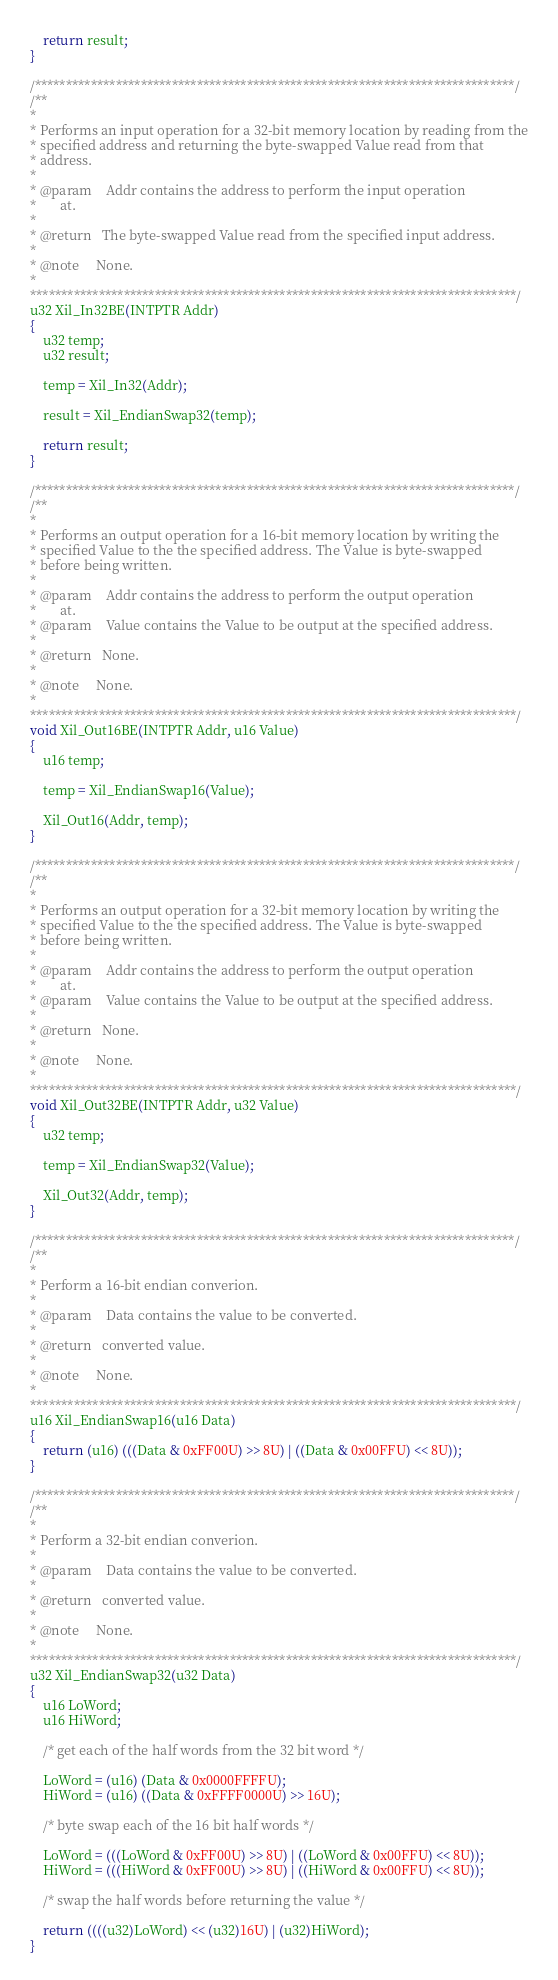Convert code to text. <code><loc_0><loc_0><loc_500><loc_500><_C_>	return result;
}

/*****************************************************************************/
/**
*
* Performs an input operation for a 32-bit memory location by reading from the
* specified address and returning the byte-swapped Value read from that
* address.
*
* @param	Addr contains the address to perform the input operation
*		at.
*
* @return	The byte-swapped Value read from the specified input address.
*
* @note		None.
*
******************************************************************************/
u32 Xil_In32BE(INTPTR Addr)
{
	u32 temp;
	u32 result;

	temp = Xil_In32(Addr);

	result = Xil_EndianSwap32(temp);

	return result;
}

/*****************************************************************************/
/**
*
* Performs an output operation for a 16-bit memory location by writing the
* specified Value to the the specified address. The Value is byte-swapped
* before being written.
*
* @param	Addr contains the address to perform the output operation
*		at.
* @param	Value contains the Value to be output at the specified address.
*
* @return	None.
*
* @note		None.
*
******************************************************************************/
void Xil_Out16BE(INTPTR Addr, u16 Value)
{
	u16 temp;

	temp = Xil_EndianSwap16(Value);

    Xil_Out16(Addr, temp);
}

/*****************************************************************************/
/**
*
* Performs an output operation for a 32-bit memory location by writing the
* specified Value to the the specified address. The Value is byte-swapped
* before being written.
*
* @param	Addr contains the address to perform the output operation
*		at.
* @param	Value contains the Value to be output at the specified address.
*
* @return	None.
*
* @note		None.
*
******************************************************************************/
void Xil_Out32BE(INTPTR Addr, u32 Value)
{
	u32 temp;

	temp = Xil_EndianSwap32(Value);

    Xil_Out32(Addr, temp);
}

/*****************************************************************************/
/**
*
* Perform a 16-bit endian converion.
*
* @param	Data contains the value to be converted.
*
* @return	converted value.
*
* @note		None.
*
******************************************************************************/
u16 Xil_EndianSwap16(u16 Data)
{
	return (u16) (((Data & 0xFF00U) >> 8U) | ((Data & 0x00FFU) << 8U));
}

/*****************************************************************************/
/**
*
* Perform a 32-bit endian converion.
*
* @param	Data contains the value to be converted.
*
* @return	converted value.
*
* @note		None.
*
******************************************************************************/
u32 Xil_EndianSwap32(u32 Data)
{
	u16 LoWord;
	u16 HiWord;

	/* get each of the half words from the 32 bit word */

	LoWord = (u16) (Data & 0x0000FFFFU);
	HiWord = (u16) ((Data & 0xFFFF0000U) >> 16U);

	/* byte swap each of the 16 bit half words */

	LoWord = (((LoWord & 0xFF00U) >> 8U) | ((LoWord & 0x00FFU) << 8U));
	HiWord = (((HiWord & 0xFF00U) >> 8U) | ((HiWord & 0x00FFU) << 8U));

	/* swap the half words before returning the value */

	return ((((u32)LoWord) << (u32)16U) | (u32)HiWord);
}
</code> 